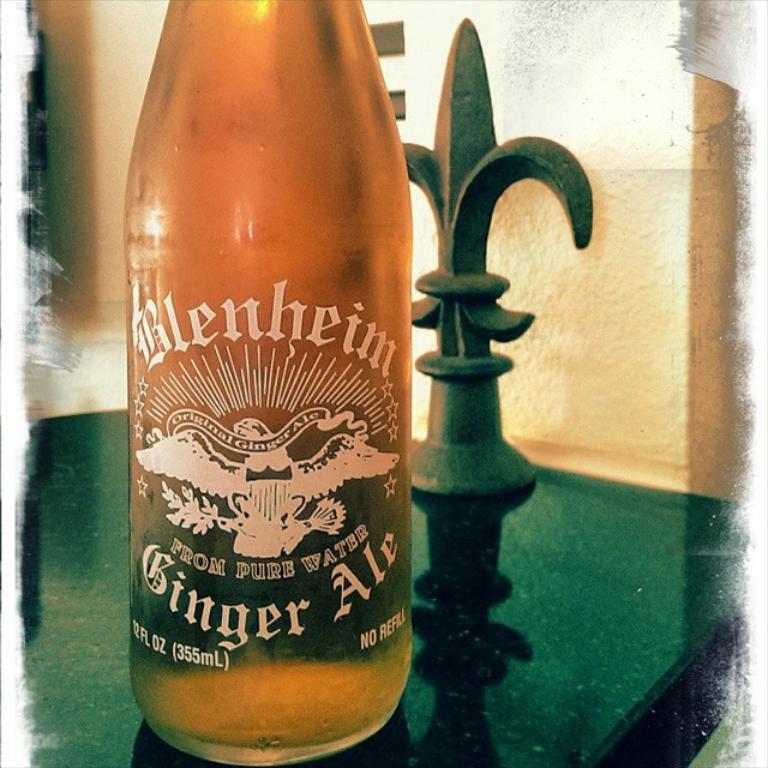In one or two sentences, can you explain what this image depicts? This picture shows a bottle on the table 